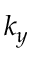Convert formula to latex. <formula><loc_0><loc_0><loc_500><loc_500>k _ { y }</formula> 